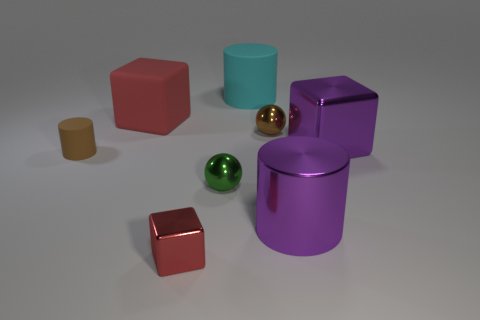Subtract all big rubber cylinders. How many cylinders are left? 2 Subtract all red cubes. How many were subtracted if there are1red cubes left? 1 Subtract 3 cubes. How many cubes are left? 0 Subtract all brown cubes. Subtract all gray cylinders. How many cubes are left? 3 Subtract all red cylinders. How many brown balls are left? 1 Subtract all large brown metallic cylinders. Subtract all small brown metal objects. How many objects are left? 7 Add 7 large cyan objects. How many large cyan objects are left? 8 Add 3 tiny green things. How many tiny green things exist? 4 Add 1 large green matte objects. How many objects exist? 9 Subtract all brown cylinders. How many cylinders are left? 2 